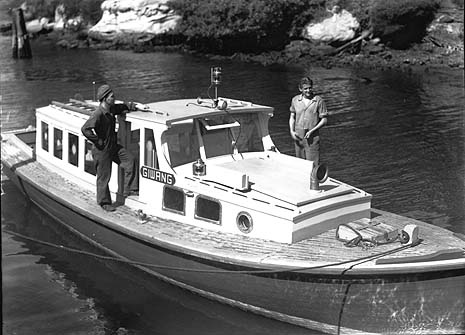Read and extract the text from this image. GIWANG 